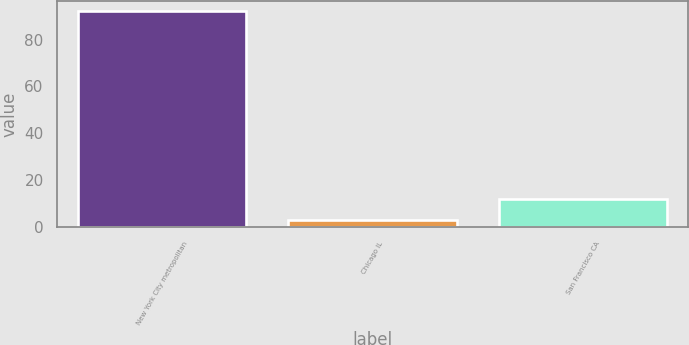Convert chart. <chart><loc_0><loc_0><loc_500><loc_500><bar_chart><fcel>New York City metropolitan<fcel>Chicago IL<fcel>San Francisco CA<nl><fcel>92<fcel>3<fcel>11.9<nl></chart> 